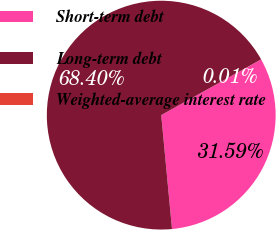Convert chart. <chart><loc_0><loc_0><loc_500><loc_500><pie_chart><fcel>Short-term debt<fcel>Long-term debt<fcel>Weighted-average interest rate<nl><fcel>31.59%<fcel>68.4%<fcel>0.01%<nl></chart> 